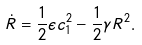Convert formula to latex. <formula><loc_0><loc_0><loc_500><loc_500>\dot { R } = \frac { 1 } { 2 } \epsilon c _ { 1 } ^ { 2 } - \frac { 1 } { 2 } \gamma R ^ { 2 } .</formula> 